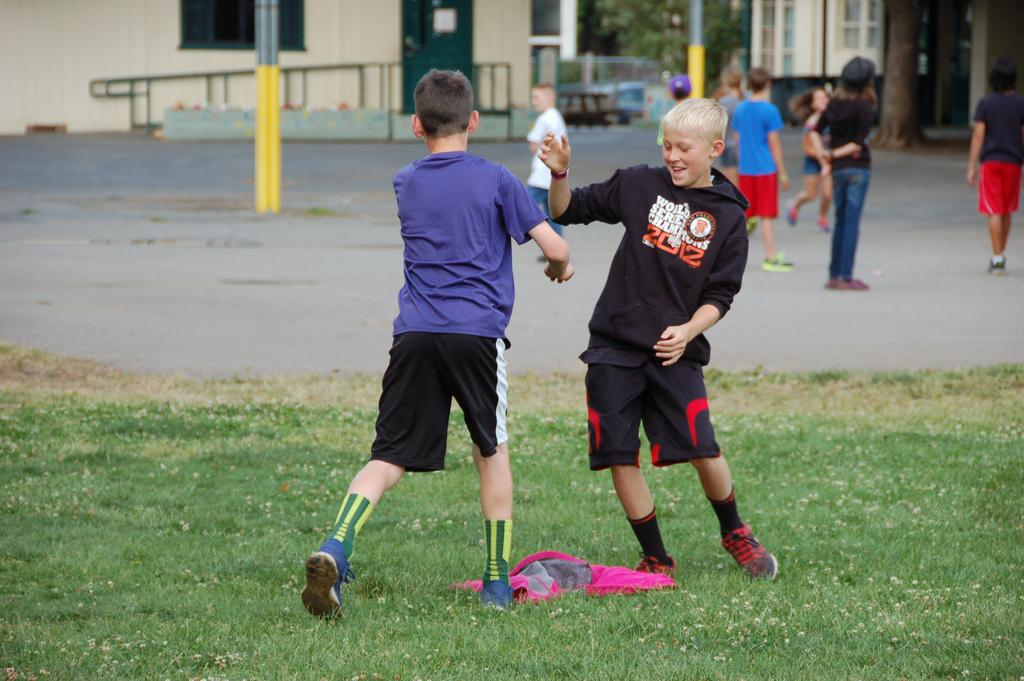How many people are in the image? There is a group of people in the image. What can be observed about the clothing of the people in the image? The people are wearing different color dresses. Where are two of the people located in the image? Two people are on the grass. What structures can be seen in the background of the image? There are poles, trees, and buildings visible in the background of the image. How many hands are visible in the image? There is no specific mention of hands in the image, so it is not possible to determine the number of hands visible. 